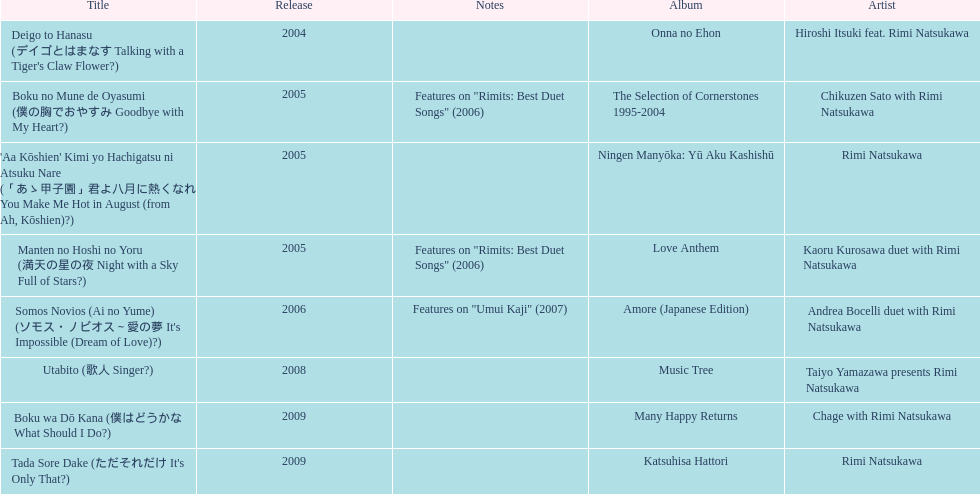Which was not released in 2004, onna no ehon or music tree? Music Tree. 